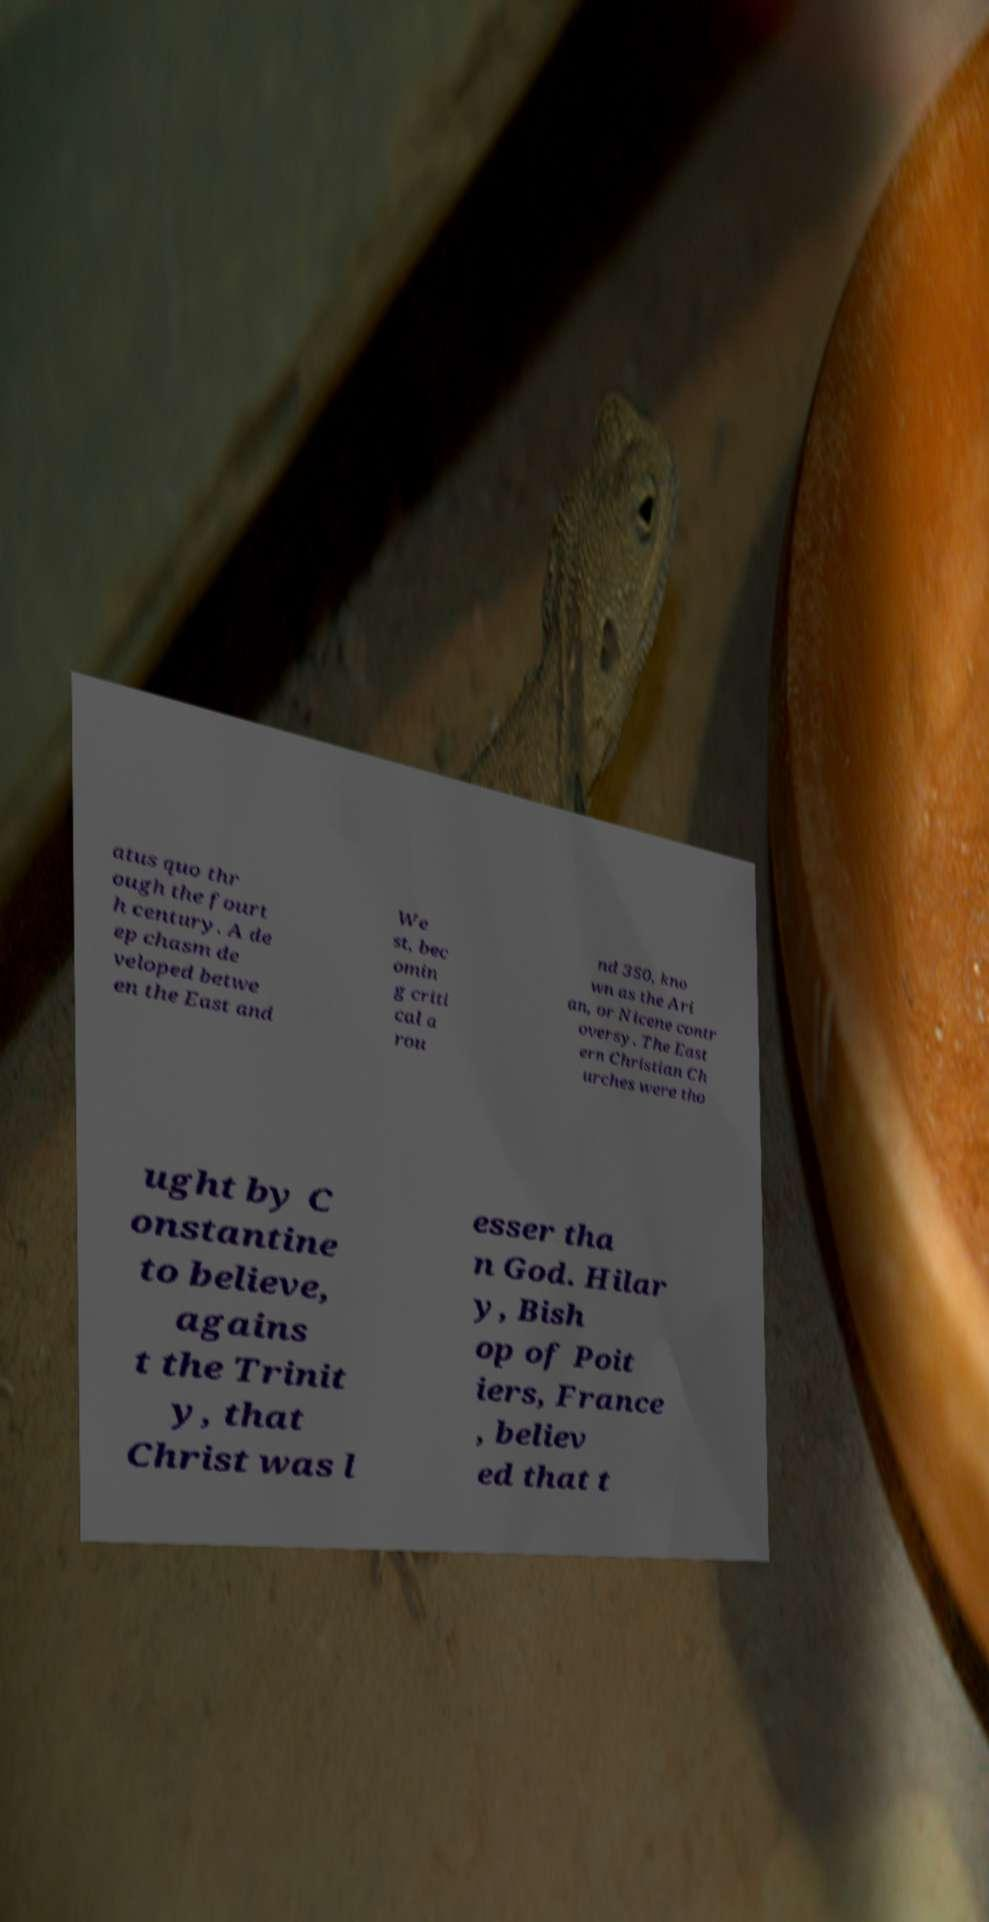For documentation purposes, I need the text within this image transcribed. Could you provide that? atus quo thr ough the fourt h century. A de ep chasm de veloped betwe en the East and We st, bec omin g criti cal a rou nd 350, kno wn as the Ari an, or Nicene contr oversy. The East ern Christian Ch urches were tho ught by C onstantine to believe, agains t the Trinit y, that Christ was l esser tha n God. Hilar y, Bish op of Poit iers, France , believ ed that t 